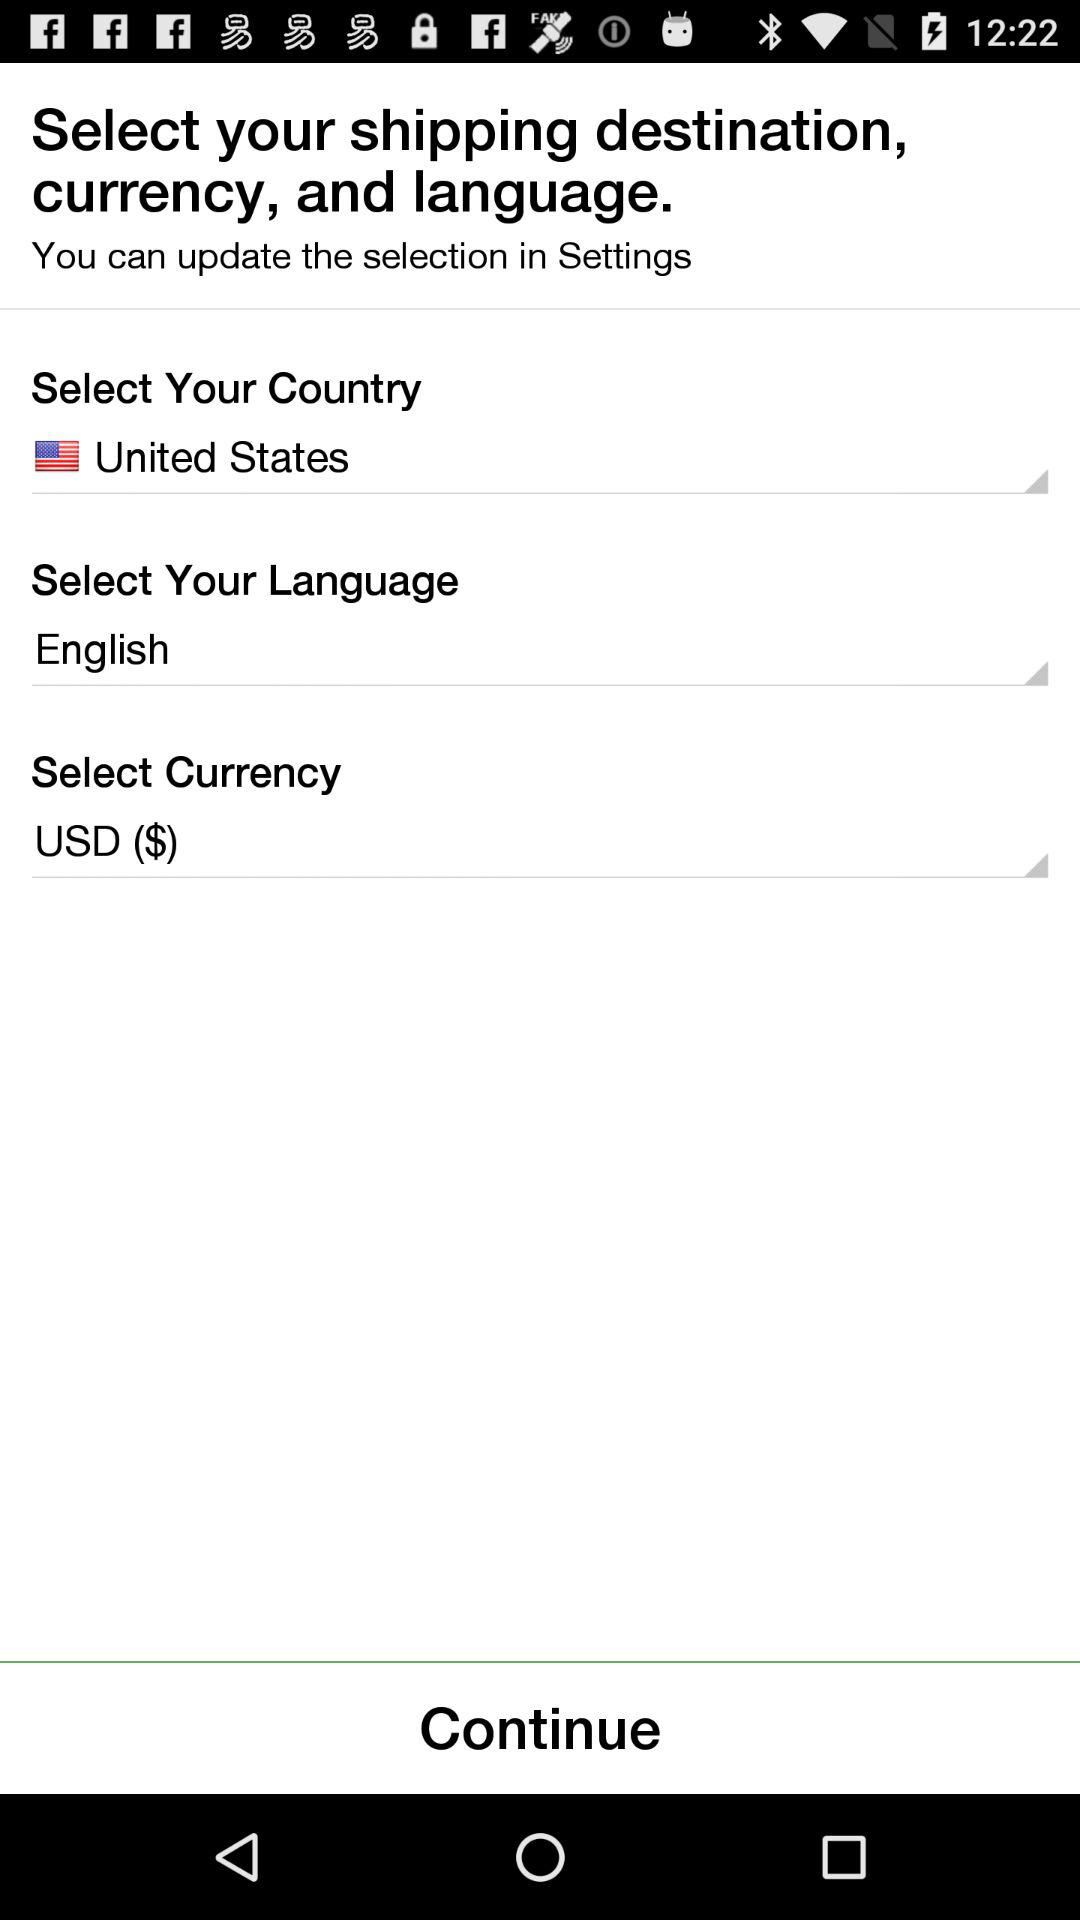What is the selected currency? The selected currency is USD ($). 